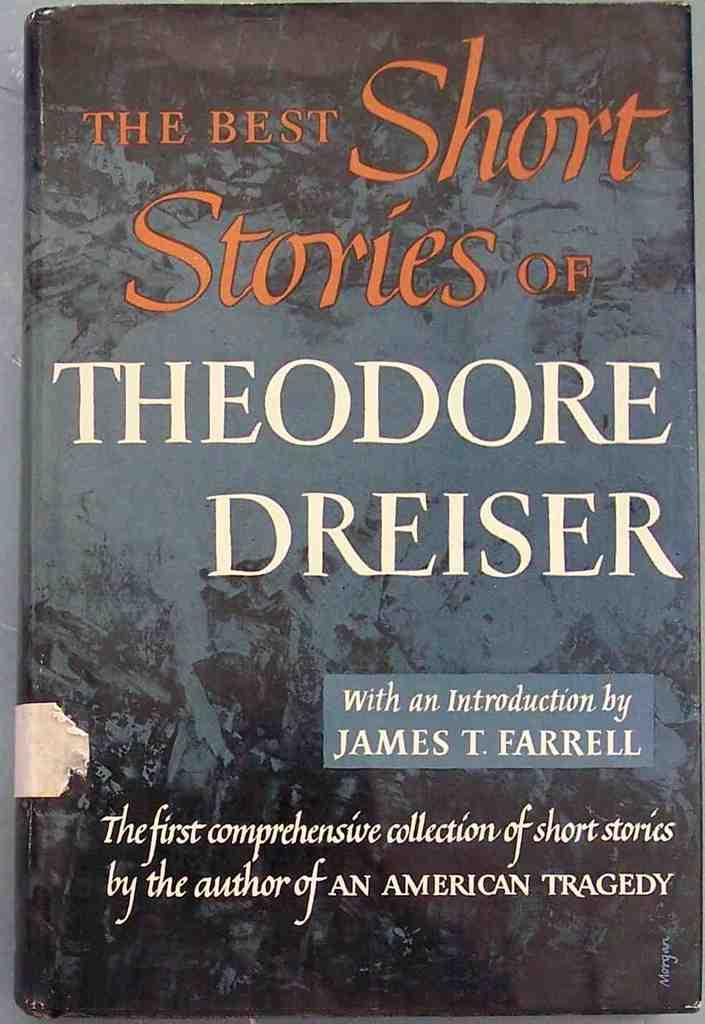Provide a one-sentence caption for the provided image. The book cover of The Best Short Sories of Theodore Dreiser is shown. 